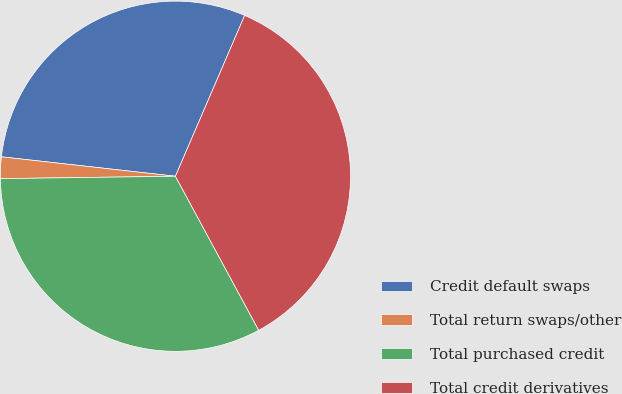Convert chart to OTSL. <chart><loc_0><loc_0><loc_500><loc_500><pie_chart><fcel>Credit default swaps<fcel>Total return swaps/other<fcel>Total purchased credit<fcel>Total credit derivatives<nl><fcel>29.7%<fcel>1.99%<fcel>32.67%<fcel>35.64%<nl></chart> 